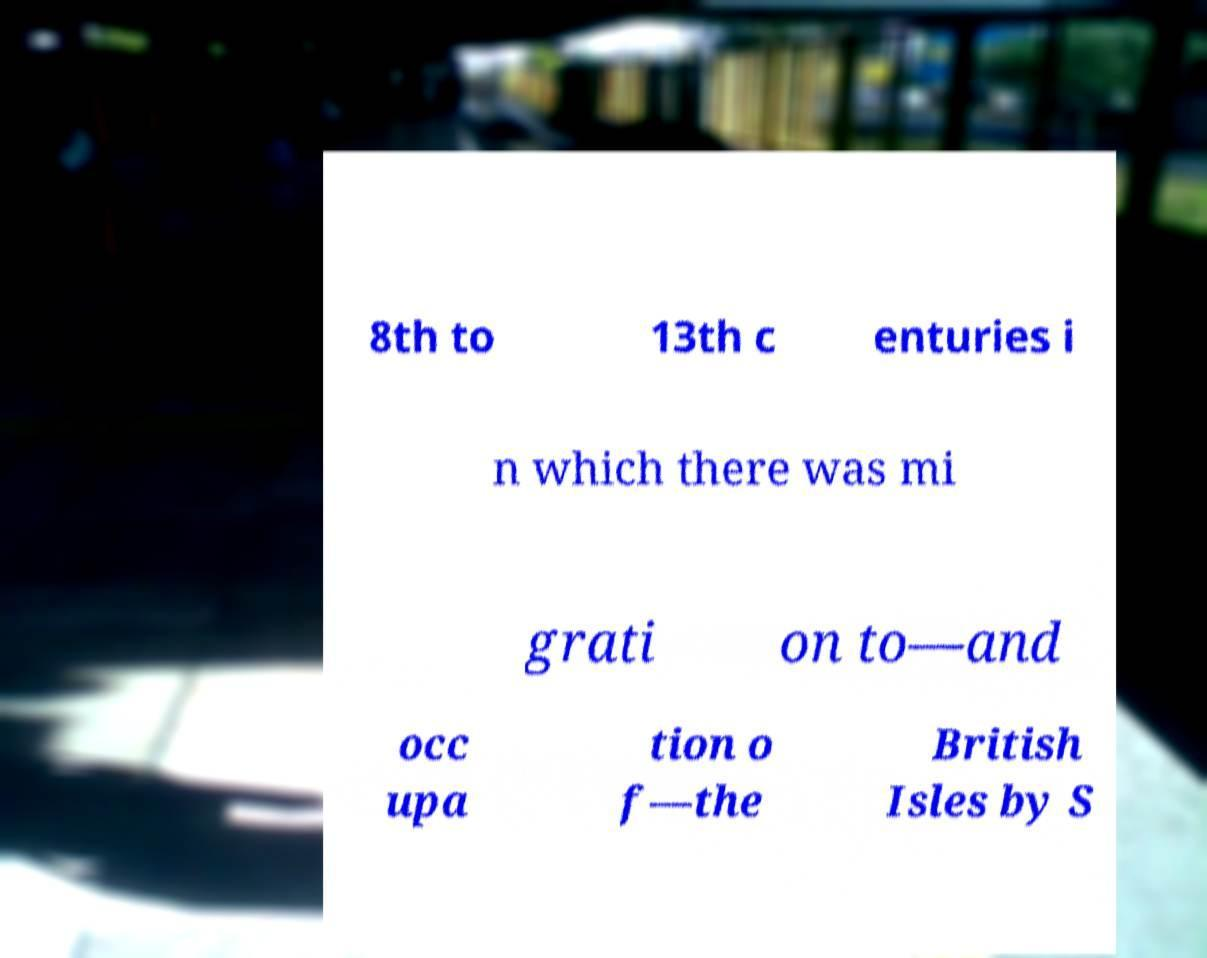Please read and relay the text visible in this image. What does it say? 8th to 13th c enturies i n which there was mi grati on to—and occ upa tion o f—the British Isles by S 